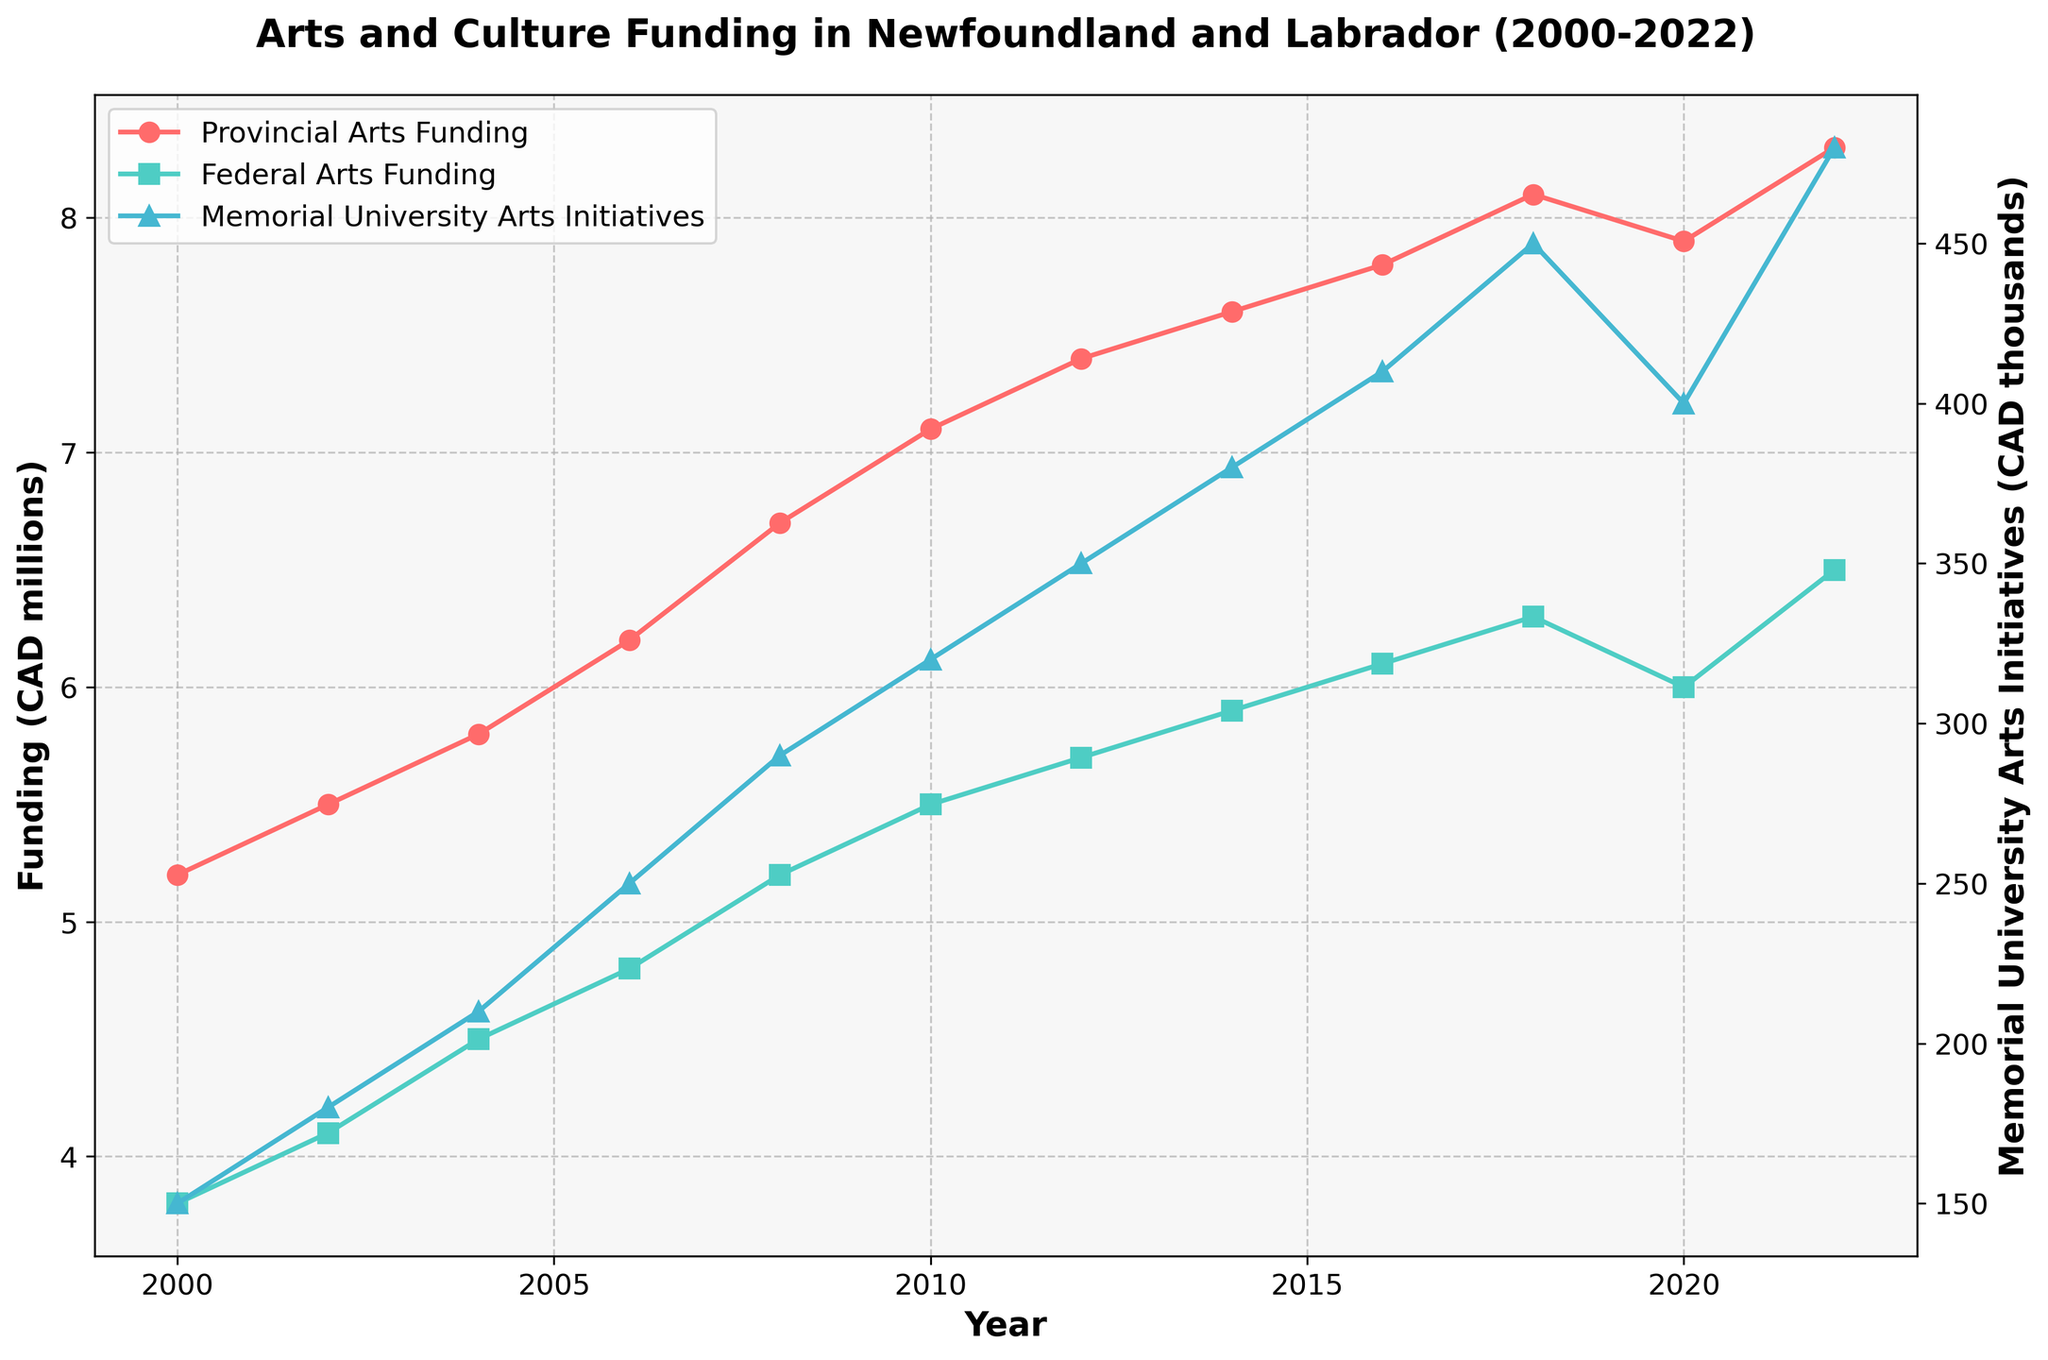What's the total Provincial Arts Funding from 2000 to 2022? Sum up all the Provincial Arts Funding amounts for each year: 5.2 + 5.5 + 5.8 + 6.2 + 6.7 + 7.1 + 7.4 + 7.6 + 7.8 + 8.1 + 7.9 + 8.3 = 84.6 million CAD
Answer: 84.6 million CAD How did Federal Arts Funding change between 2020 and 2022? Find the difference between the Federal Arts Funding in 2022 and 2020: 6.5 - 6.0 = 0.5 million CAD
Answer: Increased by 0.5 million CAD Which year had the highest funding for Memorial University Arts Initiatives? Look at the plotted data to identify the year with the highest value in the Memorial University Arts Initiatives series. The highest point is in 2022 with 480 thousand CAD
Answer: 2022 Compare Provincial and Federal Arts Funding trends from 2000 to 2022. Both trends show an overall increase over time, with Provincial Arts Funding generally higher than Federal Arts Funding throughout the period. The Provincial Funding has a slight dip in 2020 while Federal Funding remains relatively steady around that time
Answer: Both increased, Provincial higher How much did Memorial University Arts Initiatives funding increase between 2000 and 2022? Subtract the funding in 2000 from the funding in 2022: 480 thousand - 150 thousand = 330 thousand CAD
Answer: 330 thousand CAD What was the trend of Provincial Arts Funding around 2020? Provincial Arts Funding peaked at 8.1 million in 2018, slightly decreased to 7.9 million in 2020, and then increased again to 8.3 million in 2022
Answer: Peaked in 2018, slight decrease, then increased What was the Provincial Arts Funding in 2010, and how does it compare to Federal Arts Funding the same year? The Provincial Arts Funding in 2010 was 7.1 million CAD, while the Federal Arts Funding was 5.5 million CAD. Comparison: 7.1 - 5.5 = 1.6 million CAD more for Provincial
Answer: 7.1 million CAD, 1.6 million CAD more What's the average Federal Arts Funding over the given years? Sum up all the Federal Arts Funding amounts and divide by the number of years: (3.8 + 4.1 + 4.5 + 4.8 + 5.2 + 5.5 + 5.7 + 5.9 + 6.1 + 6.3 + 6.0 + 6.5) / 12 = 5.225 million CAD
Answer: 5.225 million CAD In which year did the funding for Memorial University Arts Initiatives first exceed 300 thousand CAD? Look at the data points for Memorial University Arts Initiatives and find the first year value exceeds 300 thousand CAD. In 2010, it was 320 thousand CAD, the first value above 300 thousand CAD
Answer: 2010 